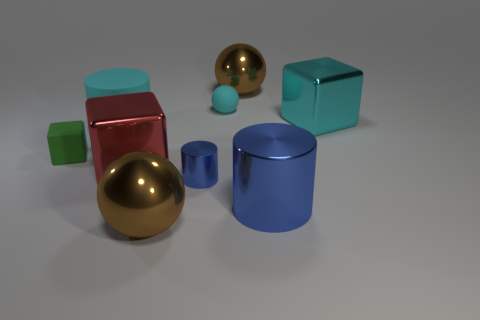Add 1 blue cylinders. How many objects exist? 10 Subtract all blocks. How many objects are left? 6 Subtract 0 brown cylinders. How many objects are left? 9 Subtract all brown metallic things. Subtract all cyan balls. How many objects are left? 6 Add 5 large red cubes. How many large red cubes are left? 6 Add 8 big red metallic blocks. How many big red metallic blocks exist? 9 